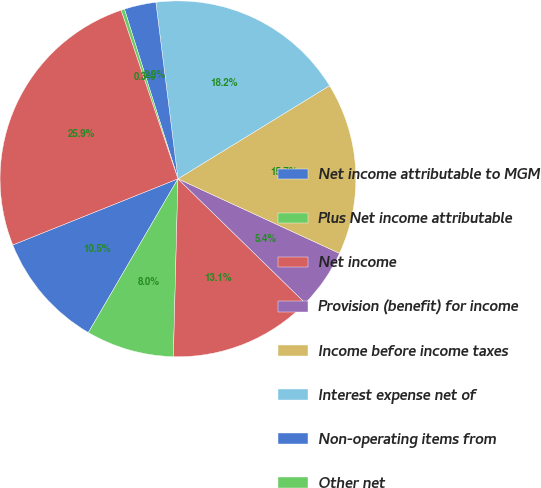Convert chart to OTSL. <chart><loc_0><loc_0><loc_500><loc_500><pie_chart><fcel>Net income attributable to MGM<fcel>Plus Net income attributable<fcel>Net income<fcel>Provision (benefit) for income<fcel>Income before income taxes<fcel>Interest expense net of<fcel>Non-operating items from<fcel>Other net<fcel>Operating income<nl><fcel>10.54%<fcel>7.99%<fcel>13.1%<fcel>5.43%<fcel>15.65%<fcel>18.21%<fcel>2.88%<fcel>0.32%<fcel>25.88%<nl></chart> 